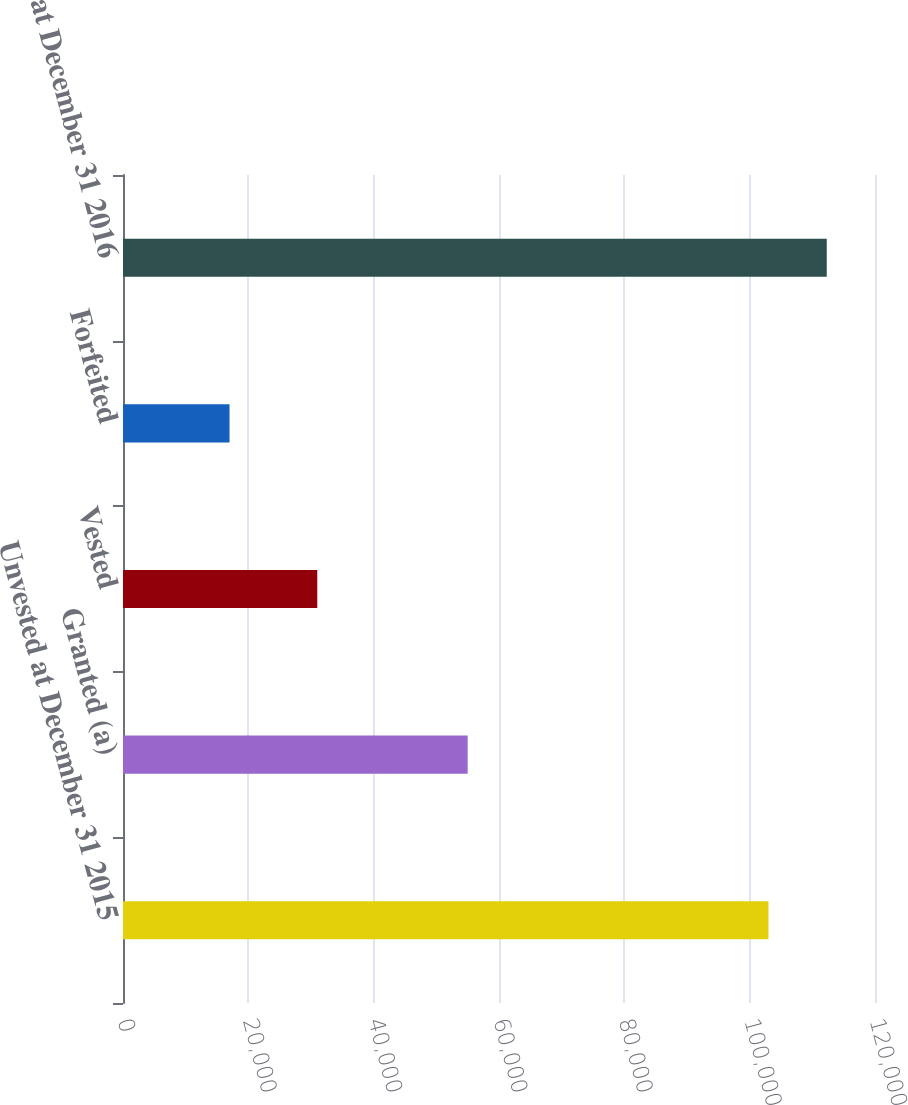Convert chart. <chart><loc_0><loc_0><loc_500><loc_500><bar_chart><fcel>Unvested at December 31 2015<fcel>Granted (a)<fcel>Vested<fcel>Forfeited<fcel>Unvested at December 31 2016<nl><fcel>103000<fcel>55000<fcel>31000<fcel>17000<fcel>112300<nl></chart> 